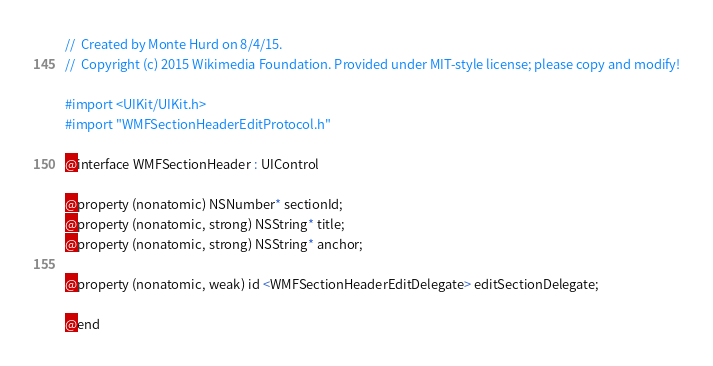Convert code to text. <code><loc_0><loc_0><loc_500><loc_500><_C_>//  Created by Monte Hurd on 8/4/15.
//  Copyright (c) 2015 Wikimedia Foundation. Provided under MIT-style license; please copy and modify!

#import <UIKit/UIKit.h>
#import "WMFSectionHeaderEditProtocol.h"

@interface WMFSectionHeader : UIControl

@property (nonatomic) NSNumber* sectionId;
@property (nonatomic, strong) NSString* title;
@property (nonatomic, strong) NSString* anchor;

@property (nonatomic, weak) id <WMFSectionHeaderEditDelegate> editSectionDelegate;

@end
</code> 